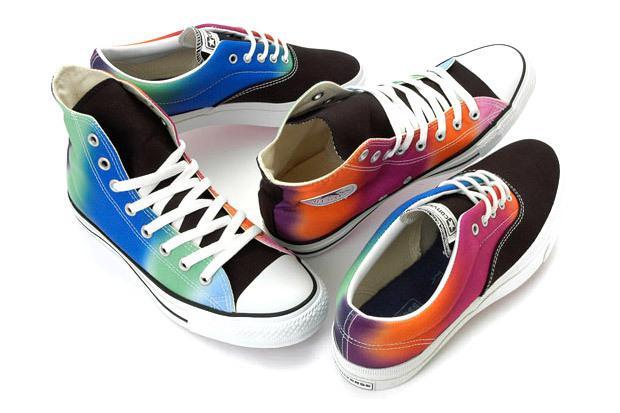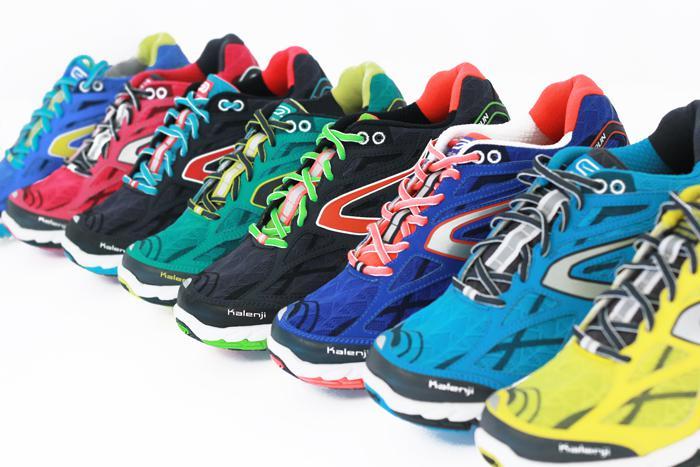The first image is the image on the left, the second image is the image on the right. Evaluate the accuracy of this statement regarding the images: "1 of the images has 1 shoe facing right in the foreground.". Is it true? Answer yes or no. No. The first image is the image on the left, the second image is the image on the right. Evaluate the accuracy of this statement regarding the images: "At least one image shows exactly one pair of shoes.". Is it true? Answer yes or no. No. 